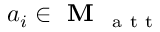<formula> <loc_0><loc_0><loc_500><loc_500>a _ { i } \in M _ { a t t }</formula> 